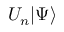<formula> <loc_0><loc_0><loc_500><loc_500>U _ { n } | \Psi \rangle</formula> 